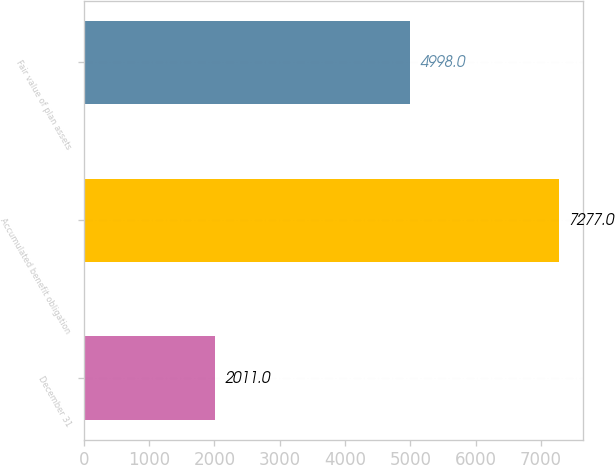<chart> <loc_0><loc_0><loc_500><loc_500><bar_chart><fcel>December 31<fcel>Accumulated benefit obligation<fcel>Fair value of plan assets<nl><fcel>2011<fcel>7277<fcel>4998<nl></chart> 